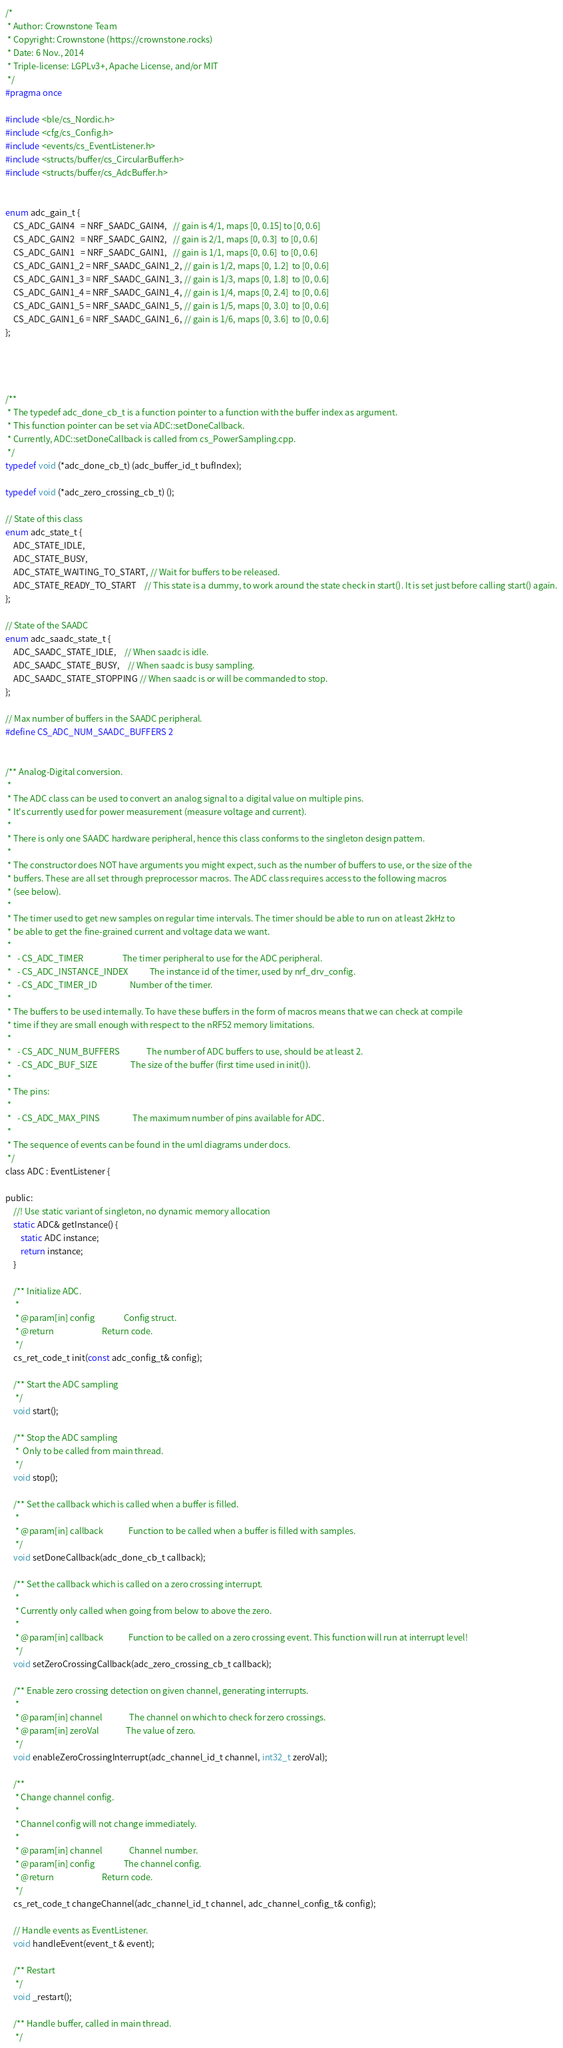Convert code to text. <code><loc_0><loc_0><loc_500><loc_500><_C_>/*
 * Author: Crownstone Team
 * Copyright: Crownstone (https://crownstone.rocks)
 * Date: 6 Nov., 2014
 * Triple-license: LGPLv3+, Apache License, and/or MIT
 */
#pragma once

#include <ble/cs_Nordic.h>
#include <cfg/cs_Config.h>
#include <events/cs_EventListener.h>
#include <structs/buffer/cs_CircularBuffer.h>
#include <structs/buffer/cs_AdcBuffer.h>


enum adc_gain_t {
	CS_ADC_GAIN4   = NRF_SAADC_GAIN4,   // gain is 4/1, maps [0, 0.15] to [0, 0.6]
	CS_ADC_GAIN2   = NRF_SAADC_GAIN2,   // gain is 2/1, maps [0, 0.3]  to [0, 0.6]
	CS_ADC_GAIN1   = NRF_SAADC_GAIN1,   // gain is 1/1, maps [0, 0.6]  to [0, 0.6]
	CS_ADC_GAIN1_2 = NRF_SAADC_GAIN1_2, // gain is 1/2, maps [0, 1.2]  to [0, 0.6]
	CS_ADC_GAIN1_3 = NRF_SAADC_GAIN1_3, // gain is 1/3, maps [0, 1.8]  to [0, 0.6]
	CS_ADC_GAIN1_4 = NRF_SAADC_GAIN1_4, // gain is 1/4, maps [0, 2.4]  to [0, 0.6]
	CS_ADC_GAIN1_5 = NRF_SAADC_GAIN1_5, // gain is 1/5, maps [0, 3.0]  to [0, 0.6]
	CS_ADC_GAIN1_6 = NRF_SAADC_GAIN1_6, // gain is 1/6, maps [0, 3.6]  to [0, 0.6]
};




/**
 * The typedef adc_done_cb_t is a function pointer to a function with the buffer index as argument.
 * This function pointer can be set via ADC::setDoneCallback.
 * Currently, ADC::setDoneCallback is called from cs_PowerSampling.cpp.
 */
typedef void (*adc_done_cb_t) (adc_buffer_id_t bufIndex);

typedef void (*adc_zero_crossing_cb_t) ();

// State of this class
enum adc_state_t {
	ADC_STATE_IDLE,
	ADC_STATE_BUSY,
	ADC_STATE_WAITING_TO_START, // Wait for buffers to be released.
	ADC_STATE_READY_TO_START    // This state is a dummy, to work around the state check in start(). It is set just before calling start() again.
};

// State of the SAADC
enum adc_saadc_state_t {
	ADC_SAADC_STATE_IDLE,    // When saadc is idle.
	ADC_SAADC_STATE_BUSY,    // When saadc is busy sampling.
	ADC_SAADC_STATE_STOPPING // When saadc is or will be commanded to stop.
};

// Max number of buffers in the SAADC peripheral.
#define CS_ADC_NUM_SAADC_BUFFERS 2


/** Analog-Digital conversion.
 *
 * The ADC class can be used to convert an analog signal to a digital value on multiple pins.
 * It's currently used for power measurement (measure voltage and current).
 *
 * There is only one SAADC hardware peripheral, hence this class conforms to the singleton design pattern.
 *
 * The constructor does NOT have arguments you might expect, such as the number of buffers to use, or the size of the
 * buffers. These are all set through preprocessor macros. The ADC class requires access to the following macros
 * (see below).
 *
 * The timer used to get new samples on regular time intervals. The timer should be able to run on at least 2kHz to
 * be able to get the fine-grained current and voltage data we want.
 *
 *   - CS_ADC_TIMER                    The timer peripheral to use for the ADC peripheral.
 *   - CS_ADC_INSTANCE_INDEX           The instance id of the timer, used by nrf_drv_config.
 *   - CS_ADC_TIMER_ID                 Number of the timer.
 *
 * The buffers to be used internally. To have these buffers in the form of macros means that we can check at compile
 * time if they are small enough with respect to the nRF52 memory limitations.
 *
 *   - CS_ADC_NUM_BUFFERS              The number of ADC buffers to use, should be at least 2.
 *   - CS_ADC_BUF_SIZE                 The size of the buffer (first time used in init()).
 *
 * The pins:
 *
 *   - CS_ADC_MAX_PINS                 The maximum number of pins available for ADC.
 *
 * The sequence of events can be found in the uml diagrams under docs.
 */
class ADC : EventListener {

public:
	//! Use static variant of singleton, no dynamic memory allocation
	static ADC& getInstance() {
		static ADC instance;
		return instance;
	}

	/** Initialize ADC.
	 *
	 * @param[in] config               Config struct.
	 * @return                         Return code.
	 */
	cs_ret_code_t init(const adc_config_t& config);

	/** Start the ADC sampling
	 */
	void start();

	/** Stop the ADC sampling
	 *  Only to be called from main thread.
	 */
	void stop();

	/** Set the callback which is called when a buffer is filled.
	 *
	 * @param[in] callback             Function to be called when a buffer is filled with samples.
	 */
	void setDoneCallback(adc_done_cb_t callback);

	/** Set the callback which is called on a zero crossing interrupt.
	 *
	 * Currently only called when going from below to above the zero.
	 *
	 * @param[in] callback             Function to be called on a zero crossing event. This function will run at interrupt level!
	 */
	void setZeroCrossingCallback(adc_zero_crossing_cb_t callback);

	/** Enable zero crossing detection on given channel, generating interrupts.
	 *
	 * @param[in] channel              The channel on which to check for zero crossings.
	 * @param[in] zeroVal              The value of zero.
	 */
	void enableZeroCrossingInterrupt(adc_channel_id_t channel, int32_t zeroVal);

	/**
	 * Change channel config.
	 *
	 * Channel config will not change immediately.
	 *
	 * @param[in] channel              Channel number.
	 * @param[in] config               The channel config.
	 * @return                         Return code.
	 */
	cs_ret_code_t changeChannel(adc_channel_id_t channel, adc_channel_config_t& config);

	// Handle events as EventListener.
	void handleEvent(event_t & event);

	/** Restart
	 */
	void _restart();

	/** Handle buffer, called in main thread.
	 */</code> 